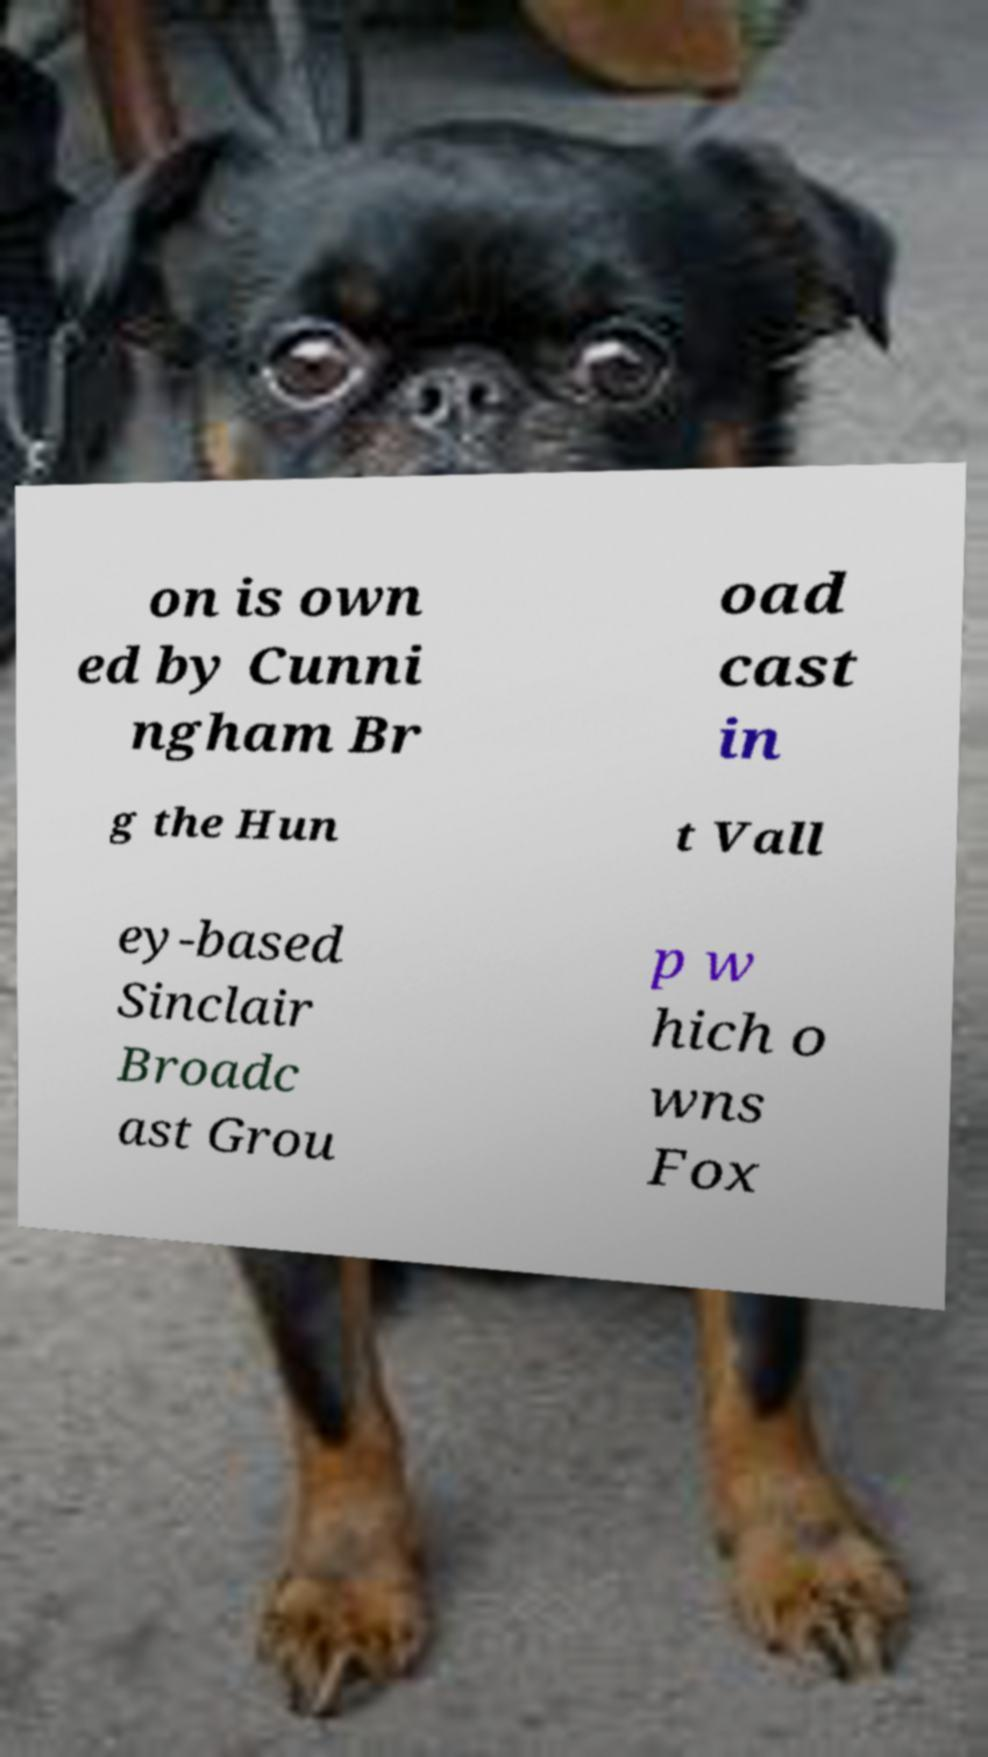Could you assist in decoding the text presented in this image and type it out clearly? on is own ed by Cunni ngham Br oad cast in g the Hun t Vall ey-based Sinclair Broadc ast Grou p w hich o wns Fox 